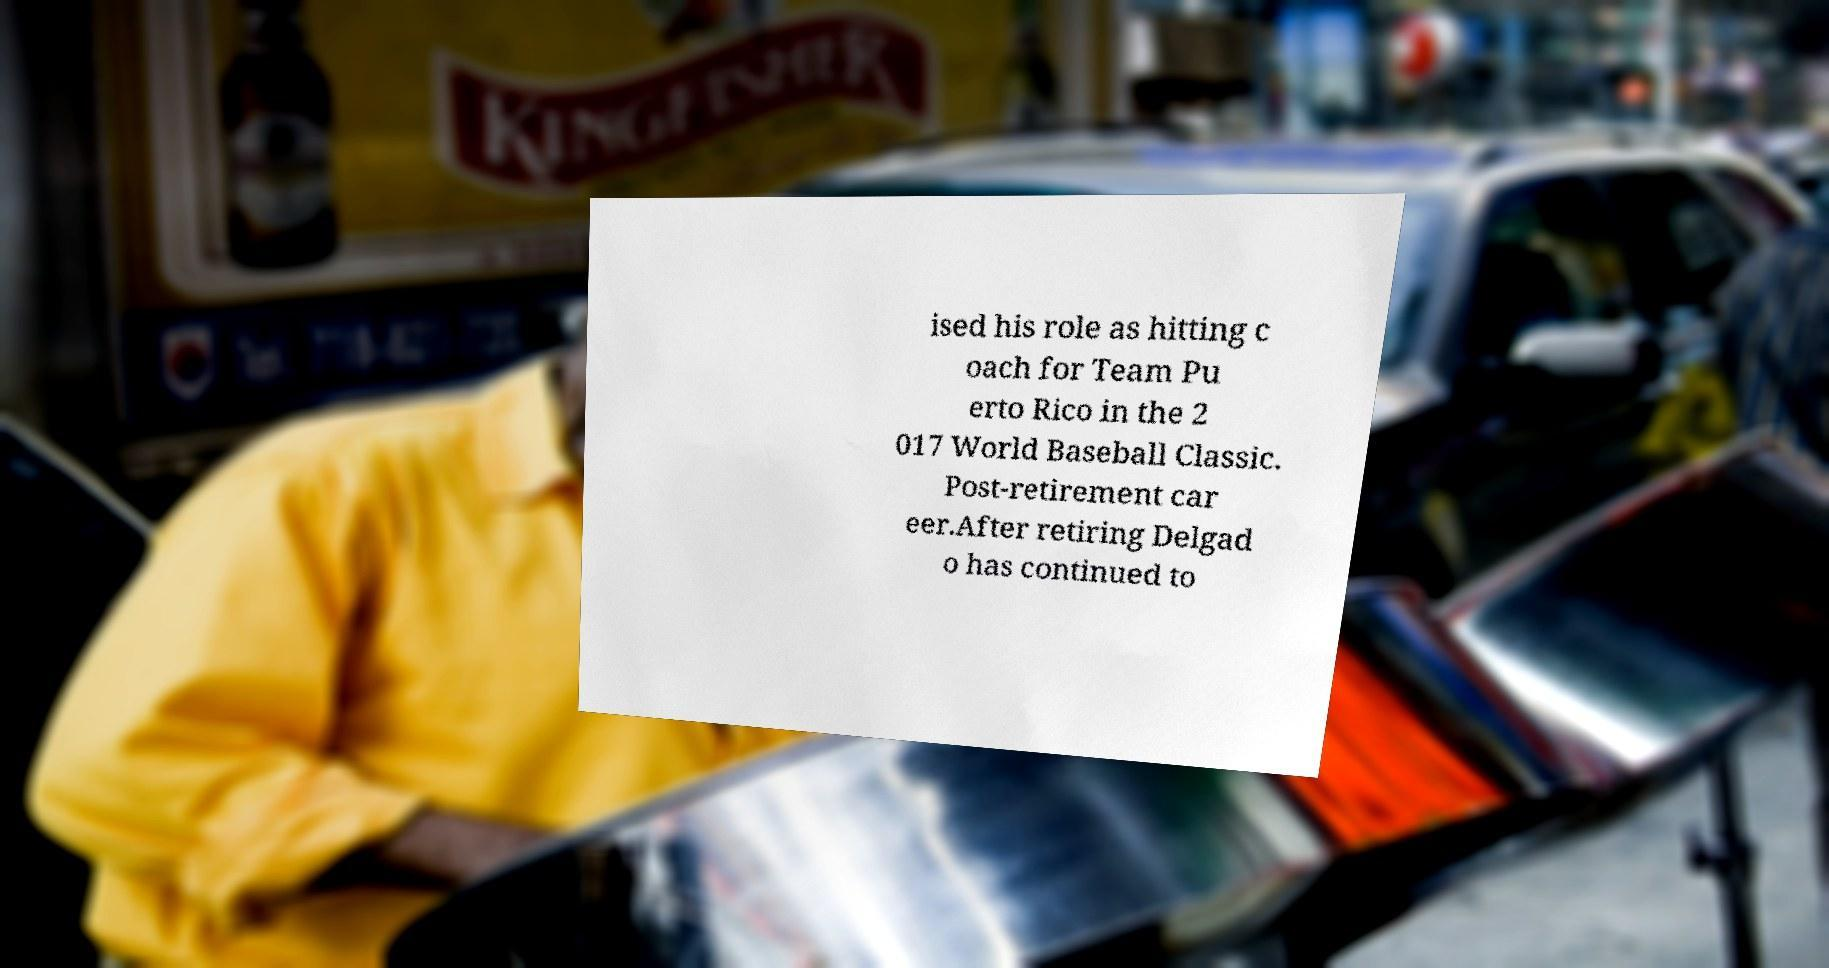Please read and relay the text visible in this image. What does it say? ised his role as hitting c oach for Team Pu erto Rico in the 2 017 World Baseball Classic. Post-retirement car eer.After retiring Delgad o has continued to 